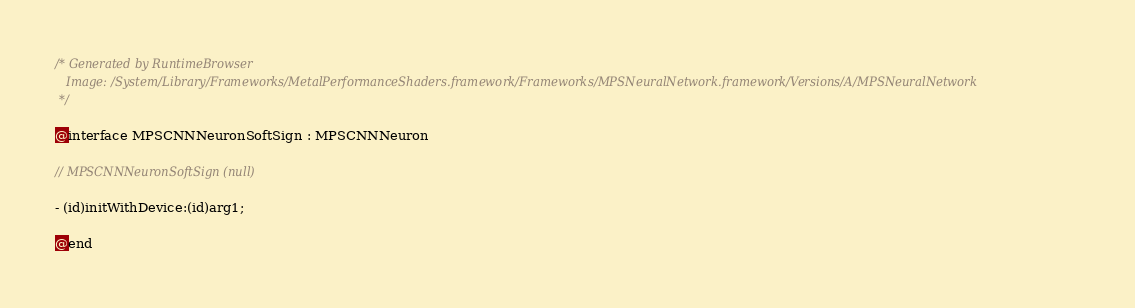Convert code to text. <code><loc_0><loc_0><loc_500><loc_500><_C_>/* Generated by RuntimeBrowser
   Image: /System/Library/Frameworks/MetalPerformanceShaders.framework/Frameworks/MPSNeuralNetwork.framework/Versions/A/MPSNeuralNetwork
 */

@interface MPSCNNNeuronSoftSign : MPSCNNNeuron

// MPSCNNNeuronSoftSign (null)

- (id)initWithDevice:(id)arg1;

@end
</code> 